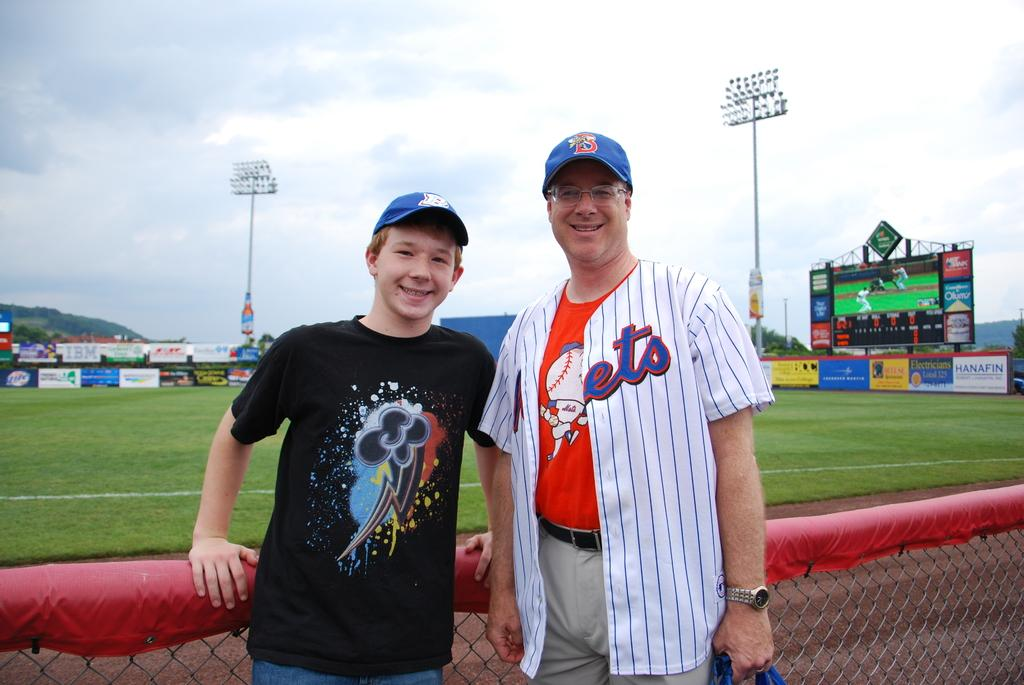<image>
Render a clear and concise summary of the photo. a father wearing a mets baseball shirt and son posing in front of a gamefield 